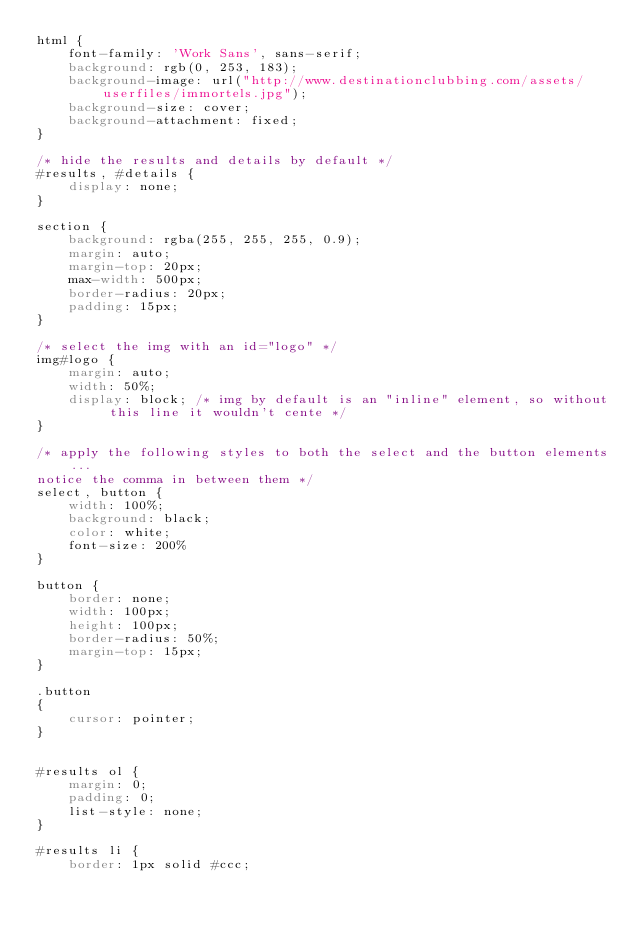Convert code to text. <code><loc_0><loc_0><loc_500><loc_500><_CSS_>html {
    font-family: 'Work Sans', sans-serif;
    background: rgb(0, 253, 183);
    background-image: url("http://www.destinationclubbing.com/assets/userfiles/immortels.jpg");
    background-size: cover;
    background-attachment: fixed;
}

/* hide the results and details by default */
#results, #details {
    display: none;
}

section {
    background: rgba(255, 255, 255, 0.9);
    margin: auto;
    margin-top: 20px;
    max-width: 500px;
    border-radius: 20px;
    padding: 15px;
}

/* select the img with an id="logo" */
img#logo {
    margin: auto;
    width: 50%;
    display: block; /* img by default is an "inline" element, so without this line it wouldn't cente */
}

/* apply the following styles to both the select and the button elements...
notice the comma in between them */
select, button {
    width: 100%;
    background: black;
    color: white;
    font-size: 200%
}

button {
    border: none;
    width: 100px;
    height: 100px;
    border-radius: 50%;
    margin-top: 15px;
}

.button
{
    cursor: pointer;
}


#results ol {
    margin: 0;
    padding: 0;
    list-style: none;
}

#results li {
    border: 1px solid #ccc;</code> 